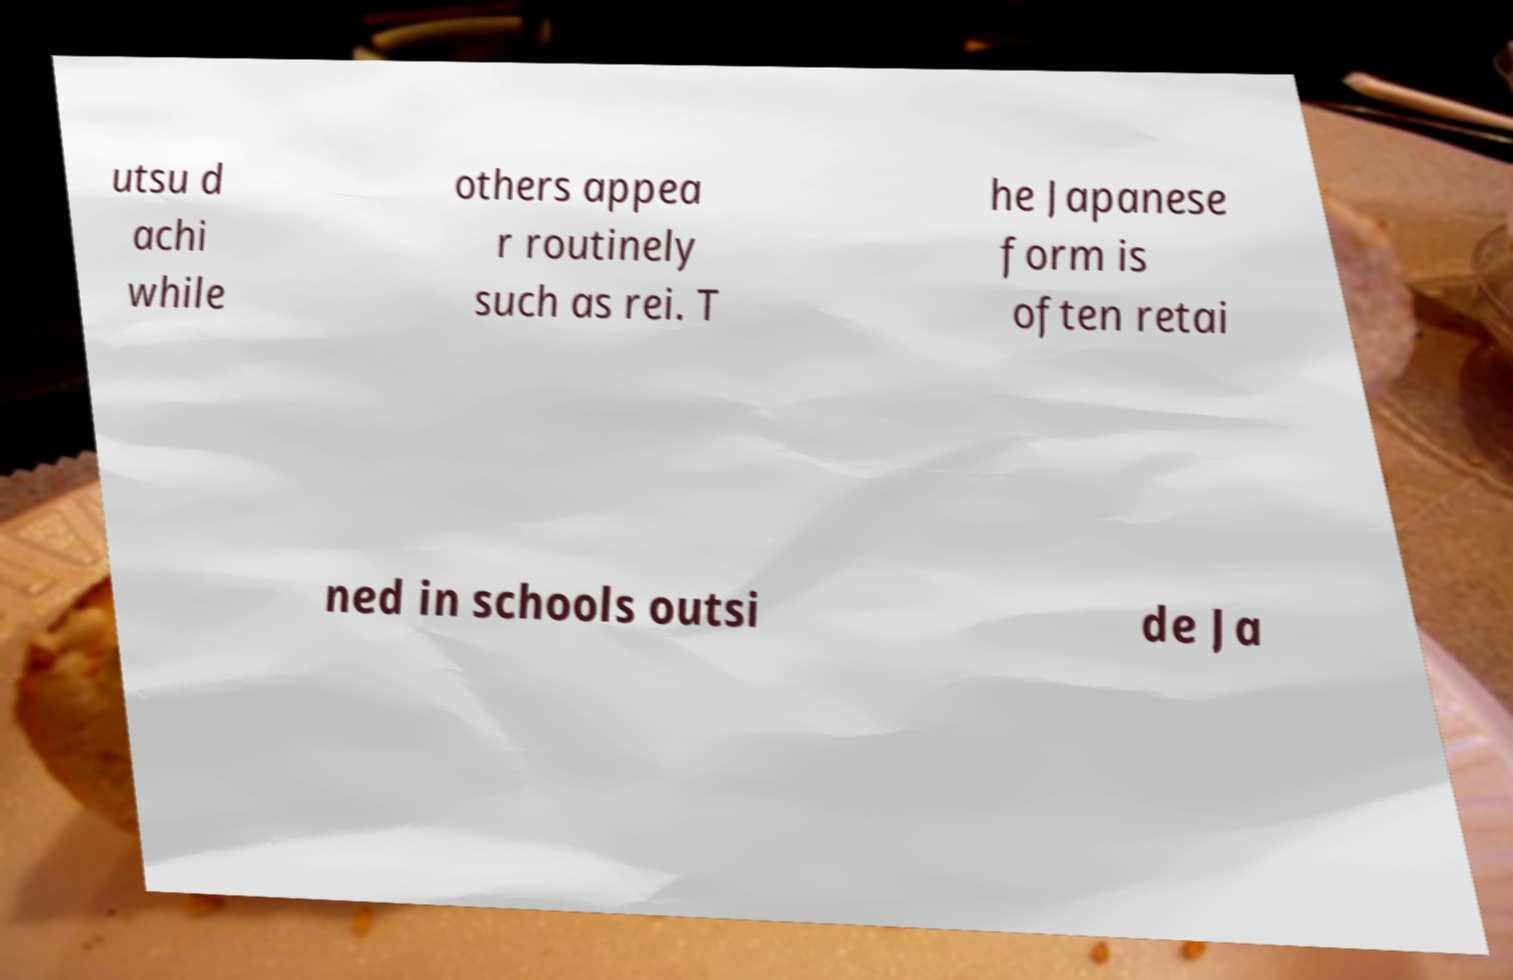What messages or text are displayed in this image? I need them in a readable, typed format. utsu d achi while others appea r routinely such as rei. T he Japanese form is often retai ned in schools outsi de Ja 